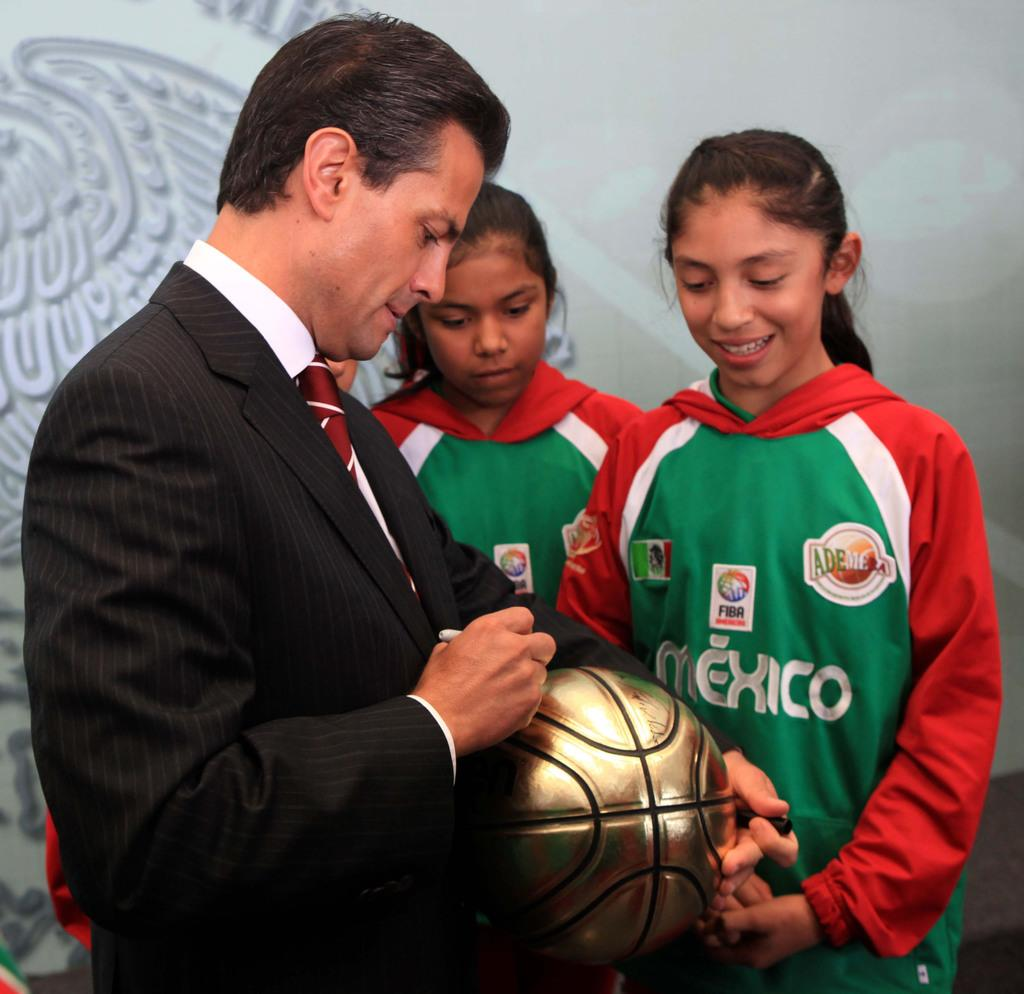<image>
Describe the image concisely. A man signs a ball for two girls in Mexico uniforms. 